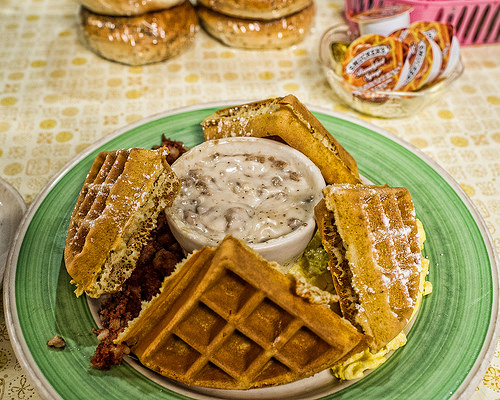<image>
Can you confirm if the syrup is to the left of the waffles? No. The syrup is not to the left of the waffles. From this viewpoint, they have a different horizontal relationship. 